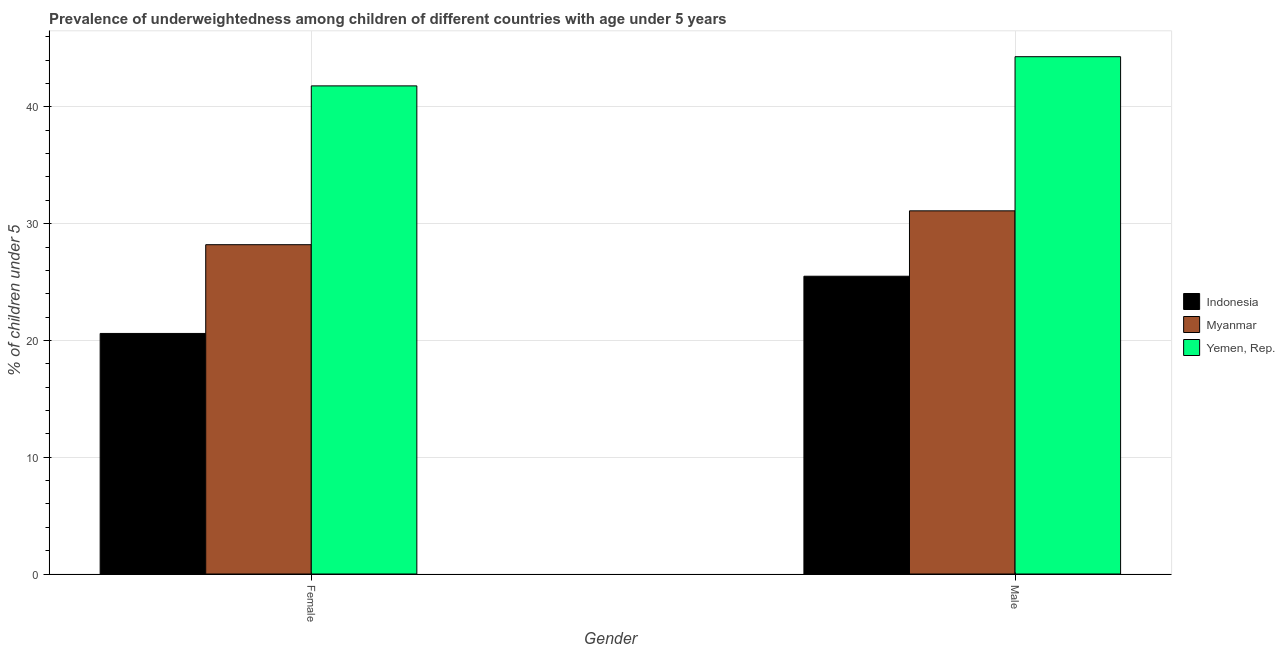How many groups of bars are there?
Give a very brief answer. 2. Are the number of bars per tick equal to the number of legend labels?
Ensure brevity in your answer.  Yes. How many bars are there on the 2nd tick from the right?
Keep it short and to the point. 3. What is the label of the 1st group of bars from the left?
Provide a succinct answer. Female. What is the percentage of underweighted male children in Myanmar?
Your answer should be compact. 31.1. Across all countries, what is the maximum percentage of underweighted male children?
Give a very brief answer. 44.3. Across all countries, what is the minimum percentage of underweighted male children?
Offer a very short reply. 25.5. In which country was the percentage of underweighted female children maximum?
Ensure brevity in your answer.  Yemen, Rep. In which country was the percentage of underweighted female children minimum?
Provide a succinct answer. Indonesia. What is the total percentage of underweighted female children in the graph?
Your answer should be compact. 90.6. What is the difference between the percentage of underweighted female children in Indonesia and that in Myanmar?
Provide a succinct answer. -7.6. What is the difference between the percentage of underweighted male children in Myanmar and the percentage of underweighted female children in Yemen, Rep.?
Your answer should be compact. -10.7. What is the average percentage of underweighted female children per country?
Make the answer very short. 30.2. What is the difference between the percentage of underweighted female children and percentage of underweighted male children in Myanmar?
Offer a very short reply. -2.9. What is the ratio of the percentage of underweighted female children in Yemen, Rep. to that in Myanmar?
Your response must be concise. 1.48. In how many countries, is the percentage of underweighted male children greater than the average percentage of underweighted male children taken over all countries?
Ensure brevity in your answer.  1. What does the 2nd bar from the left in Female represents?
Provide a short and direct response. Myanmar. How many bars are there?
Keep it short and to the point. 6. Are all the bars in the graph horizontal?
Offer a terse response. No. What is the difference between two consecutive major ticks on the Y-axis?
Your response must be concise. 10. Are the values on the major ticks of Y-axis written in scientific E-notation?
Provide a short and direct response. No. Does the graph contain any zero values?
Provide a short and direct response. No. Does the graph contain grids?
Offer a very short reply. Yes. How are the legend labels stacked?
Make the answer very short. Vertical. What is the title of the graph?
Your answer should be very brief. Prevalence of underweightedness among children of different countries with age under 5 years. What is the label or title of the Y-axis?
Give a very brief answer.  % of children under 5. What is the  % of children under 5 in Indonesia in Female?
Offer a terse response. 20.6. What is the  % of children under 5 of Myanmar in Female?
Your response must be concise. 28.2. What is the  % of children under 5 of Yemen, Rep. in Female?
Make the answer very short. 41.8. What is the  % of children under 5 in Myanmar in Male?
Your answer should be very brief. 31.1. What is the  % of children under 5 in Yemen, Rep. in Male?
Provide a succinct answer. 44.3. Across all Gender, what is the maximum  % of children under 5 of Indonesia?
Ensure brevity in your answer.  25.5. Across all Gender, what is the maximum  % of children under 5 in Myanmar?
Offer a very short reply. 31.1. Across all Gender, what is the maximum  % of children under 5 in Yemen, Rep.?
Your response must be concise. 44.3. Across all Gender, what is the minimum  % of children under 5 of Indonesia?
Your answer should be very brief. 20.6. Across all Gender, what is the minimum  % of children under 5 in Myanmar?
Make the answer very short. 28.2. Across all Gender, what is the minimum  % of children under 5 of Yemen, Rep.?
Give a very brief answer. 41.8. What is the total  % of children under 5 in Indonesia in the graph?
Make the answer very short. 46.1. What is the total  % of children under 5 in Myanmar in the graph?
Provide a succinct answer. 59.3. What is the total  % of children under 5 in Yemen, Rep. in the graph?
Provide a short and direct response. 86.1. What is the difference between the  % of children under 5 in Indonesia in Female and that in Male?
Ensure brevity in your answer.  -4.9. What is the difference between the  % of children under 5 of Indonesia in Female and the  % of children under 5 of Yemen, Rep. in Male?
Offer a terse response. -23.7. What is the difference between the  % of children under 5 of Myanmar in Female and the  % of children under 5 of Yemen, Rep. in Male?
Provide a short and direct response. -16.1. What is the average  % of children under 5 of Indonesia per Gender?
Offer a terse response. 23.05. What is the average  % of children under 5 of Myanmar per Gender?
Provide a short and direct response. 29.65. What is the average  % of children under 5 in Yemen, Rep. per Gender?
Offer a terse response. 43.05. What is the difference between the  % of children under 5 in Indonesia and  % of children under 5 in Myanmar in Female?
Offer a terse response. -7.6. What is the difference between the  % of children under 5 of Indonesia and  % of children under 5 of Yemen, Rep. in Female?
Give a very brief answer. -21.2. What is the difference between the  % of children under 5 of Indonesia and  % of children under 5 of Yemen, Rep. in Male?
Your response must be concise. -18.8. What is the ratio of the  % of children under 5 of Indonesia in Female to that in Male?
Your answer should be compact. 0.81. What is the ratio of the  % of children under 5 in Myanmar in Female to that in Male?
Provide a succinct answer. 0.91. What is the ratio of the  % of children under 5 in Yemen, Rep. in Female to that in Male?
Offer a very short reply. 0.94. What is the difference between the highest and the second highest  % of children under 5 in Myanmar?
Provide a short and direct response. 2.9. What is the difference between the highest and the second highest  % of children under 5 of Yemen, Rep.?
Give a very brief answer. 2.5. What is the difference between the highest and the lowest  % of children under 5 in Myanmar?
Provide a short and direct response. 2.9. What is the difference between the highest and the lowest  % of children under 5 of Yemen, Rep.?
Your answer should be very brief. 2.5. 